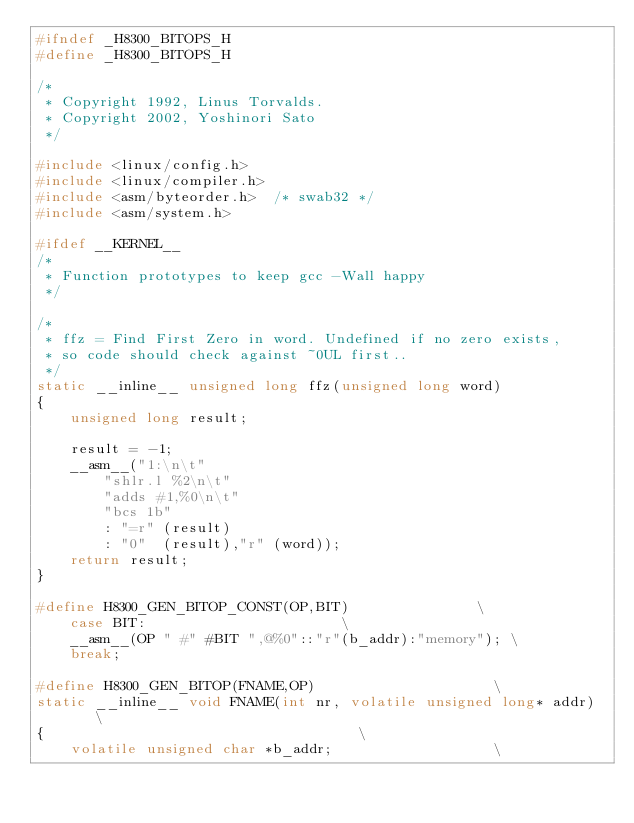<code> <loc_0><loc_0><loc_500><loc_500><_C_>#ifndef _H8300_BITOPS_H
#define _H8300_BITOPS_H

/*
 * Copyright 1992, Linus Torvalds.
 * Copyright 2002, Yoshinori Sato
 */

#include <linux/config.h>
#include <linux/compiler.h>
#include <asm/byteorder.h>	/* swab32 */
#include <asm/system.h>

#ifdef __KERNEL__
/*
 * Function prototypes to keep gcc -Wall happy
 */

/*
 * ffz = Find First Zero in word. Undefined if no zero exists,
 * so code should check against ~0UL first..
 */
static __inline__ unsigned long ffz(unsigned long word)
{
	unsigned long result;

	result = -1;
	__asm__("1:\n\t"
		"shlr.l %2\n\t"
		"adds #1,%0\n\t"
		"bcs 1b"
		: "=r" (result)
		: "0"  (result),"r" (word));
	return result;
}

#define H8300_GEN_BITOP_CONST(OP,BIT)			    \
	case BIT:					    \
	__asm__(OP " #" #BIT ",@%0"::"r"(b_addr):"memory"); \
	break;

#define H8300_GEN_BITOP(FNAME,OP)				      \
static __inline__ void FNAME(int nr, volatile unsigned long* addr)    \
{								      \
	volatile unsigned char *b_addr;				      \</code> 